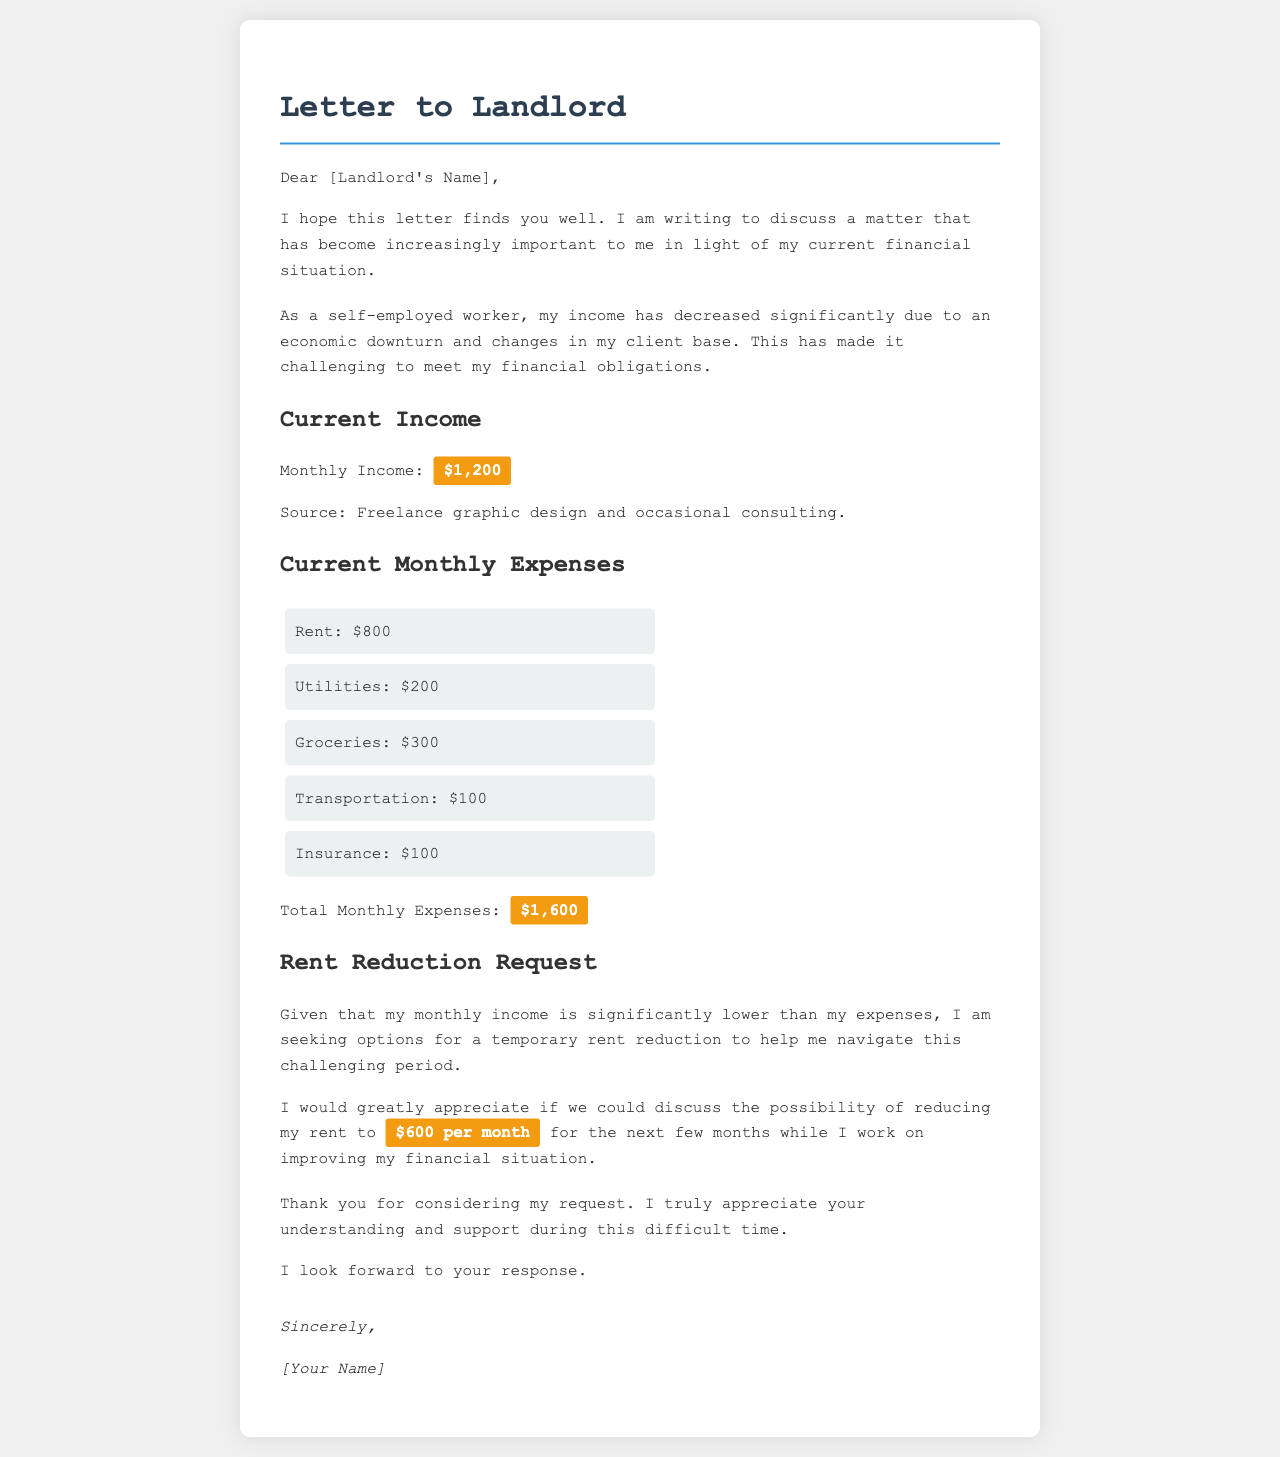What is the sender's monthly income? The letter states the sender's monthly income is clearly mentioned as $1,200.
Answer: $1,200 What is the proposed rent after reduction? The letter requests a reduction in rent to a specific amount, which is highlighted as $600 per month.
Answer: $600 per month How much does the sender spend on groceries? The document lists the groceries expense as $300 in the current monthly expenses section.
Answer: $300 What is the total amount of monthly expenses? The total monthly expenses are explicitly calculated and presented in the document as $1,600.
Answer: $1,600 What type of work does the sender do? The document mentions that the sender's sources of income include freelance graphic design and occasional consulting.
Answer: Freelance graphic design and occasional consulting Why is the sender requesting a rent reduction? The letter explains that the sender is facing financial hardship due to decreased income.
Answer: Financial hardship Who is the letter addressed to? The letter is directed towards the landlord, as indicated in the salutation.
Answer: [Landlord's Name] What is the main purpose of the letter? The main purpose of the letter is to discuss the possibility of rent reduction due to financial difficulties.
Answer: Rent reduction request 